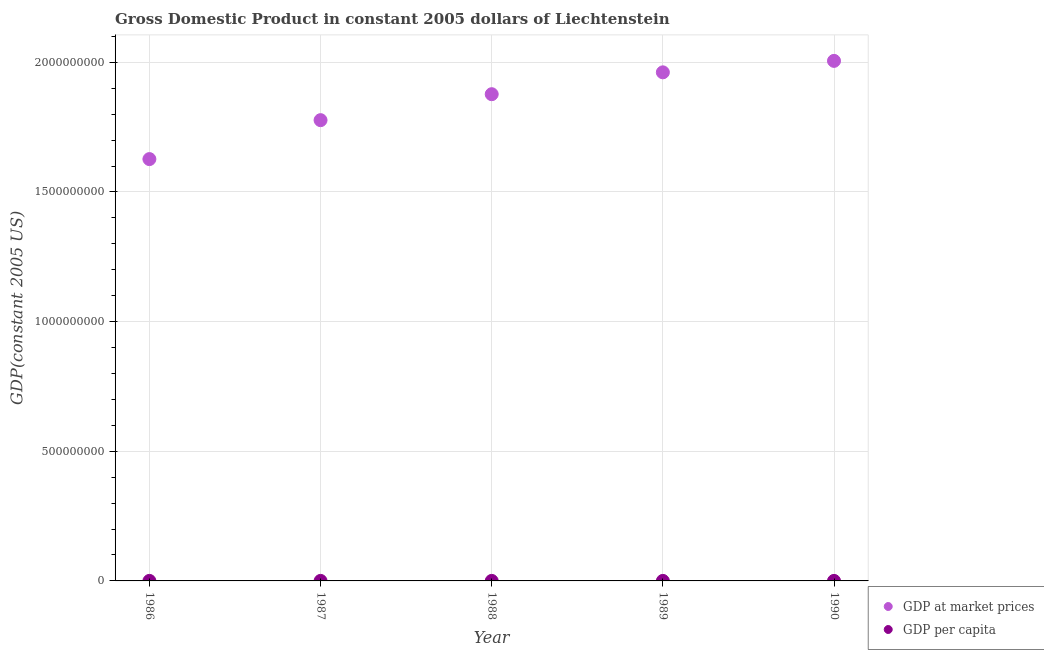What is the gdp at market prices in 1987?
Provide a succinct answer. 1.78e+09. Across all years, what is the maximum gdp at market prices?
Ensure brevity in your answer.  2.01e+09. Across all years, what is the minimum gdp at market prices?
Give a very brief answer. 1.63e+09. What is the total gdp at market prices in the graph?
Offer a terse response. 9.25e+09. What is the difference between the gdp at market prices in 1986 and that in 1988?
Keep it short and to the point. -2.50e+08. What is the difference between the gdp per capita in 1987 and the gdp at market prices in 1986?
Your answer should be compact. -1.63e+09. What is the average gdp at market prices per year?
Your answer should be compact. 1.85e+09. In the year 1989, what is the difference between the gdp per capita and gdp at market prices?
Give a very brief answer. -1.96e+09. What is the ratio of the gdp per capita in 1988 to that in 1989?
Make the answer very short. 0.97. Is the gdp per capita in 1988 less than that in 1989?
Provide a short and direct response. Yes. Is the difference between the gdp per capita in 1986 and 1987 greater than the difference between the gdp at market prices in 1986 and 1987?
Keep it short and to the point. Yes. What is the difference between the highest and the second highest gdp per capita?
Ensure brevity in your answer.  720.44. What is the difference between the highest and the lowest gdp per capita?
Your answer should be compact. 1.07e+04. In how many years, is the gdp at market prices greater than the average gdp at market prices taken over all years?
Your response must be concise. 3. Is the sum of the gdp per capita in 1989 and 1990 greater than the maximum gdp at market prices across all years?
Ensure brevity in your answer.  No. How many dotlines are there?
Provide a short and direct response. 2. How many years are there in the graph?
Your response must be concise. 5. What is the difference between two consecutive major ticks on the Y-axis?
Your response must be concise. 5.00e+08. Does the graph contain any zero values?
Provide a short and direct response. No. Where does the legend appear in the graph?
Your answer should be compact. Bottom right. How many legend labels are there?
Provide a succinct answer. 2. What is the title of the graph?
Offer a terse response. Gross Domestic Product in constant 2005 dollars of Liechtenstein. Does "DAC donors" appear as one of the legend labels in the graph?
Offer a very short reply. No. What is the label or title of the Y-axis?
Keep it short and to the point. GDP(constant 2005 US). What is the GDP(constant 2005 US) in GDP at market prices in 1986?
Give a very brief answer. 1.63e+09. What is the GDP(constant 2005 US) in GDP per capita in 1986?
Ensure brevity in your answer.  5.91e+04. What is the GDP(constant 2005 US) of GDP at market prices in 1987?
Ensure brevity in your answer.  1.78e+09. What is the GDP(constant 2005 US) in GDP per capita in 1987?
Make the answer very short. 6.39e+04. What is the GDP(constant 2005 US) of GDP at market prices in 1988?
Keep it short and to the point. 1.88e+09. What is the GDP(constant 2005 US) of GDP per capita in 1988?
Make the answer very short. 6.68e+04. What is the GDP(constant 2005 US) in GDP at market prices in 1989?
Offer a very short reply. 1.96e+09. What is the GDP(constant 2005 US) of GDP per capita in 1989?
Ensure brevity in your answer.  6.90e+04. What is the GDP(constant 2005 US) in GDP at market prices in 1990?
Provide a short and direct response. 2.01e+09. What is the GDP(constant 2005 US) in GDP per capita in 1990?
Provide a succinct answer. 6.98e+04. Across all years, what is the maximum GDP(constant 2005 US) in GDP at market prices?
Keep it short and to the point. 2.01e+09. Across all years, what is the maximum GDP(constant 2005 US) of GDP per capita?
Your answer should be very brief. 6.98e+04. Across all years, what is the minimum GDP(constant 2005 US) of GDP at market prices?
Give a very brief answer. 1.63e+09. Across all years, what is the minimum GDP(constant 2005 US) in GDP per capita?
Make the answer very short. 5.91e+04. What is the total GDP(constant 2005 US) of GDP at market prices in the graph?
Make the answer very short. 9.25e+09. What is the total GDP(constant 2005 US) of GDP per capita in the graph?
Provide a short and direct response. 3.29e+05. What is the difference between the GDP(constant 2005 US) in GDP at market prices in 1986 and that in 1987?
Your response must be concise. -1.50e+08. What is the difference between the GDP(constant 2005 US) in GDP per capita in 1986 and that in 1987?
Your answer should be very brief. -4814.73. What is the difference between the GDP(constant 2005 US) of GDP at market prices in 1986 and that in 1988?
Keep it short and to the point. -2.50e+08. What is the difference between the GDP(constant 2005 US) in GDP per capita in 1986 and that in 1988?
Keep it short and to the point. -7713.91. What is the difference between the GDP(constant 2005 US) in GDP at market prices in 1986 and that in 1989?
Your answer should be very brief. -3.35e+08. What is the difference between the GDP(constant 2005 US) of GDP per capita in 1986 and that in 1989?
Ensure brevity in your answer.  -9943.53. What is the difference between the GDP(constant 2005 US) in GDP at market prices in 1986 and that in 1990?
Your response must be concise. -3.79e+08. What is the difference between the GDP(constant 2005 US) in GDP per capita in 1986 and that in 1990?
Provide a short and direct response. -1.07e+04. What is the difference between the GDP(constant 2005 US) of GDP at market prices in 1987 and that in 1988?
Your answer should be compact. -1.00e+08. What is the difference between the GDP(constant 2005 US) of GDP per capita in 1987 and that in 1988?
Keep it short and to the point. -2899.17. What is the difference between the GDP(constant 2005 US) in GDP at market prices in 1987 and that in 1989?
Your answer should be very brief. -1.84e+08. What is the difference between the GDP(constant 2005 US) of GDP per capita in 1987 and that in 1989?
Your response must be concise. -5128.8. What is the difference between the GDP(constant 2005 US) in GDP at market prices in 1987 and that in 1990?
Provide a short and direct response. -2.29e+08. What is the difference between the GDP(constant 2005 US) of GDP per capita in 1987 and that in 1990?
Your response must be concise. -5849.24. What is the difference between the GDP(constant 2005 US) of GDP at market prices in 1988 and that in 1989?
Offer a very short reply. -8.43e+07. What is the difference between the GDP(constant 2005 US) in GDP per capita in 1988 and that in 1989?
Make the answer very short. -2229.62. What is the difference between the GDP(constant 2005 US) in GDP at market prices in 1988 and that in 1990?
Keep it short and to the point. -1.28e+08. What is the difference between the GDP(constant 2005 US) of GDP per capita in 1988 and that in 1990?
Provide a succinct answer. -2950.07. What is the difference between the GDP(constant 2005 US) in GDP at market prices in 1989 and that in 1990?
Ensure brevity in your answer.  -4.42e+07. What is the difference between the GDP(constant 2005 US) of GDP per capita in 1989 and that in 1990?
Your answer should be very brief. -720.44. What is the difference between the GDP(constant 2005 US) in GDP at market prices in 1986 and the GDP(constant 2005 US) in GDP per capita in 1987?
Your answer should be very brief. 1.63e+09. What is the difference between the GDP(constant 2005 US) of GDP at market prices in 1986 and the GDP(constant 2005 US) of GDP per capita in 1988?
Ensure brevity in your answer.  1.63e+09. What is the difference between the GDP(constant 2005 US) in GDP at market prices in 1986 and the GDP(constant 2005 US) in GDP per capita in 1989?
Ensure brevity in your answer.  1.63e+09. What is the difference between the GDP(constant 2005 US) in GDP at market prices in 1986 and the GDP(constant 2005 US) in GDP per capita in 1990?
Give a very brief answer. 1.63e+09. What is the difference between the GDP(constant 2005 US) of GDP at market prices in 1987 and the GDP(constant 2005 US) of GDP per capita in 1988?
Give a very brief answer. 1.78e+09. What is the difference between the GDP(constant 2005 US) of GDP at market prices in 1987 and the GDP(constant 2005 US) of GDP per capita in 1989?
Offer a terse response. 1.78e+09. What is the difference between the GDP(constant 2005 US) of GDP at market prices in 1987 and the GDP(constant 2005 US) of GDP per capita in 1990?
Give a very brief answer. 1.78e+09. What is the difference between the GDP(constant 2005 US) of GDP at market prices in 1988 and the GDP(constant 2005 US) of GDP per capita in 1989?
Keep it short and to the point. 1.88e+09. What is the difference between the GDP(constant 2005 US) in GDP at market prices in 1988 and the GDP(constant 2005 US) in GDP per capita in 1990?
Keep it short and to the point. 1.88e+09. What is the difference between the GDP(constant 2005 US) of GDP at market prices in 1989 and the GDP(constant 2005 US) of GDP per capita in 1990?
Your answer should be compact. 1.96e+09. What is the average GDP(constant 2005 US) of GDP at market prices per year?
Provide a succinct answer. 1.85e+09. What is the average GDP(constant 2005 US) of GDP per capita per year?
Provide a succinct answer. 6.57e+04. In the year 1986, what is the difference between the GDP(constant 2005 US) of GDP at market prices and GDP(constant 2005 US) of GDP per capita?
Your answer should be compact. 1.63e+09. In the year 1987, what is the difference between the GDP(constant 2005 US) in GDP at market prices and GDP(constant 2005 US) in GDP per capita?
Your response must be concise. 1.78e+09. In the year 1988, what is the difference between the GDP(constant 2005 US) in GDP at market prices and GDP(constant 2005 US) in GDP per capita?
Make the answer very short. 1.88e+09. In the year 1989, what is the difference between the GDP(constant 2005 US) of GDP at market prices and GDP(constant 2005 US) of GDP per capita?
Give a very brief answer. 1.96e+09. In the year 1990, what is the difference between the GDP(constant 2005 US) of GDP at market prices and GDP(constant 2005 US) of GDP per capita?
Your answer should be very brief. 2.01e+09. What is the ratio of the GDP(constant 2005 US) in GDP at market prices in 1986 to that in 1987?
Ensure brevity in your answer.  0.92. What is the ratio of the GDP(constant 2005 US) of GDP per capita in 1986 to that in 1987?
Provide a short and direct response. 0.92. What is the ratio of the GDP(constant 2005 US) in GDP at market prices in 1986 to that in 1988?
Provide a succinct answer. 0.87. What is the ratio of the GDP(constant 2005 US) of GDP per capita in 1986 to that in 1988?
Your answer should be very brief. 0.88. What is the ratio of the GDP(constant 2005 US) in GDP at market prices in 1986 to that in 1989?
Keep it short and to the point. 0.83. What is the ratio of the GDP(constant 2005 US) of GDP per capita in 1986 to that in 1989?
Offer a very short reply. 0.86. What is the ratio of the GDP(constant 2005 US) of GDP at market prices in 1986 to that in 1990?
Your response must be concise. 0.81. What is the ratio of the GDP(constant 2005 US) of GDP per capita in 1986 to that in 1990?
Your response must be concise. 0.85. What is the ratio of the GDP(constant 2005 US) of GDP at market prices in 1987 to that in 1988?
Ensure brevity in your answer.  0.95. What is the ratio of the GDP(constant 2005 US) in GDP per capita in 1987 to that in 1988?
Offer a very short reply. 0.96. What is the ratio of the GDP(constant 2005 US) of GDP at market prices in 1987 to that in 1989?
Provide a succinct answer. 0.91. What is the ratio of the GDP(constant 2005 US) of GDP per capita in 1987 to that in 1989?
Offer a terse response. 0.93. What is the ratio of the GDP(constant 2005 US) in GDP at market prices in 1987 to that in 1990?
Ensure brevity in your answer.  0.89. What is the ratio of the GDP(constant 2005 US) of GDP per capita in 1987 to that in 1990?
Provide a succinct answer. 0.92. What is the ratio of the GDP(constant 2005 US) of GDP at market prices in 1988 to that in 1989?
Make the answer very short. 0.96. What is the ratio of the GDP(constant 2005 US) in GDP per capita in 1988 to that in 1989?
Provide a short and direct response. 0.97. What is the ratio of the GDP(constant 2005 US) of GDP at market prices in 1988 to that in 1990?
Provide a succinct answer. 0.94. What is the ratio of the GDP(constant 2005 US) in GDP per capita in 1988 to that in 1990?
Offer a very short reply. 0.96. What is the ratio of the GDP(constant 2005 US) of GDP per capita in 1989 to that in 1990?
Your answer should be very brief. 0.99. What is the difference between the highest and the second highest GDP(constant 2005 US) of GDP at market prices?
Your answer should be compact. 4.42e+07. What is the difference between the highest and the second highest GDP(constant 2005 US) in GDP per capita?
Provide a short and direct response. 720.44. What is the difference between the highest and the lowest GDP(constant 2005 US) of GDP at market prices?
Make the answer very short. 3.79e+08. What is the difference between the highest and the lowest GDP(constant 2005 US) of GDP per capita?
Offer a terse response. 1.07e+04. 